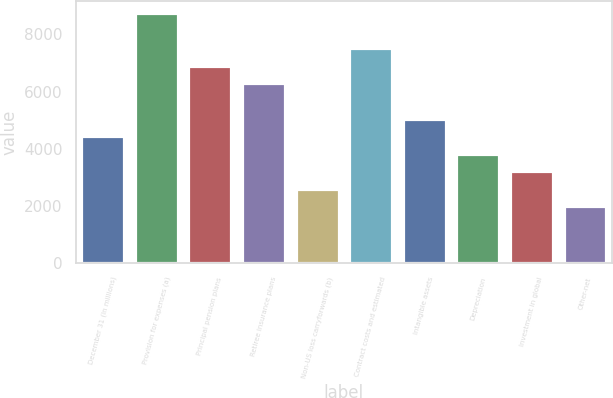<chart> <loc_0><loc_0><loc_500><loc_500><bar_chart><fcel>December 31 (In millions)<fcel>Provision for expenses (a)<fcel>Principal pension plans<fcel>Retiree insurance plans<fcel>Non-US loss carryforwards (b)<fcel>Contract costs and estimated<fcel>Intangible assets<fcel>Depreciation<fcel>Investment in global<fcel>Other-net<nl><fcel>4442.3<fcel>8739.6<fcel>6897.9<fcel>6284<fcel>2600.6<fcel>7511.8<fcel>5056.2<fcel>3828.4<fcel>3214.5<fcel>1986.7<nl></chart> 